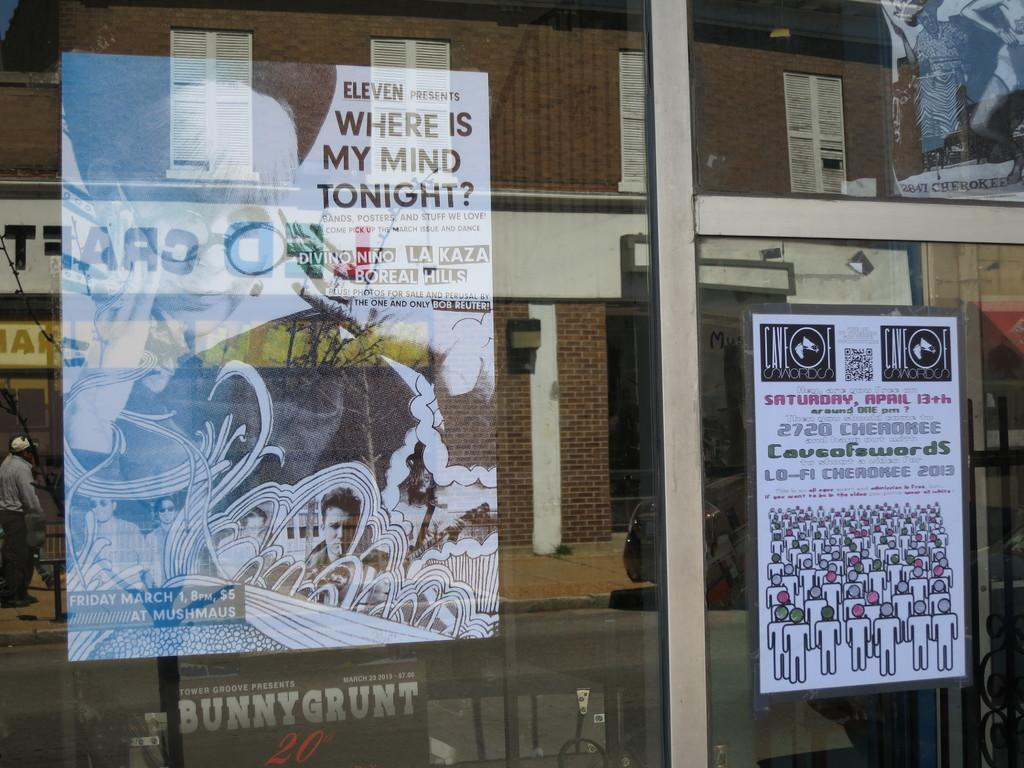What object is visible in the image? There is a glass in the image. What is placed on the glass? Posts are placed on the glass. What can be seen reflected on the glass? There are reflections of a building, a person, a road, and a car on the glass. What type of industry is depicted in the reflection of the car on the glass? There is no industry depicted in the reflection of the car on the glass; it is a reflection of a car, not an industry. 